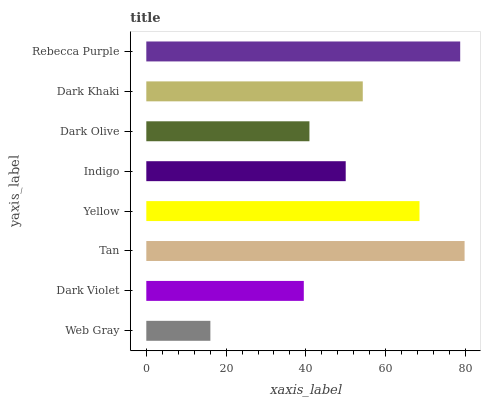Is Web Gray the minimum?
Answer yes or no. Yes. Is Tan the maximum?
Answer yes or no. Yes. Is Dark Violet the minimum?
Answer yes or no. No. Is Dark Violet the maximum?
Answer yes or no. No. Is Dark Violet greater than Web Gray?
Answer yes or no. Yes. Is Web Gray less than Dark Violet?
Answer yes or no. Yes. Is Web Gray greater than Dark Violet?
Answer yes or no. No. Is Dark Violet less than Web Gray?
Answer yes or no. No. Is Dark Khaki the high median?
Answer yes or no. Yes. Is Indigo the low median?
Answer yes or no. Yes. Is Rebecca Purple the high median?
Answer yes or no. No. Is Dark Olive the low median?
Answer yes or no. No. 